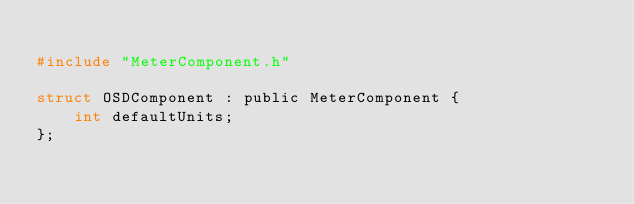Convert code to text. <code><loc_0><loc_0><loc_500><loc_500><_C_>
#include "MeterComponent.h"

struct OSDComponent : public MeterComponent {
    int defaultUnits;
};</code> 